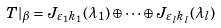<formula> <loc_0><loc_0><loc_500><loc_500>T | _ { \beta } = J _ { \varepsilon _ { 1 } k _ { 1 } } ( \lambda _ { 1 } ) \oplus \cdots \oplus J _ { \varepsilon _ { l } k _ { l } } ( \lambda _ { l } )</formula> 